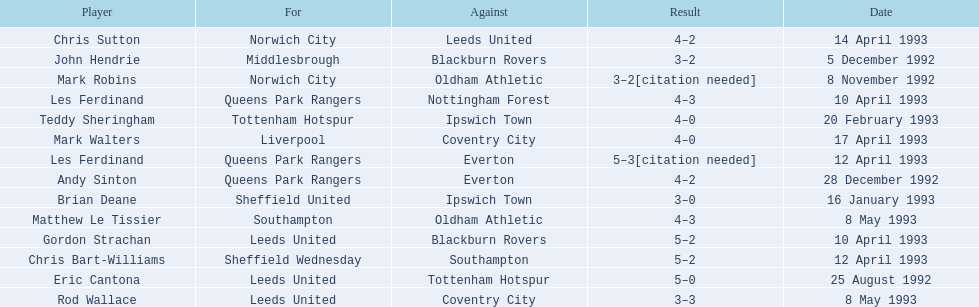Who are all the players? Eric Cantona, Mark Robins, John Hendrie, Andy Sinton, Brian Deane, Teddy Sheringham, Gordon Strachan, Les Ferdinand, Chris Bart-Williams, Les Ferdinand, Chris Sutton, Mark Walters, Rod Wallace, Matthew Le Tissier. What were their results? 5–0, 3–2[citation needed], 3–2, 4–2, 3–0, 4–0, 5–2, 4–3, 5–2, 5–3[citation needed], 4–2, 4–0, 3–3, 4–3. Which player tied with mark robins? John Hendrie. 